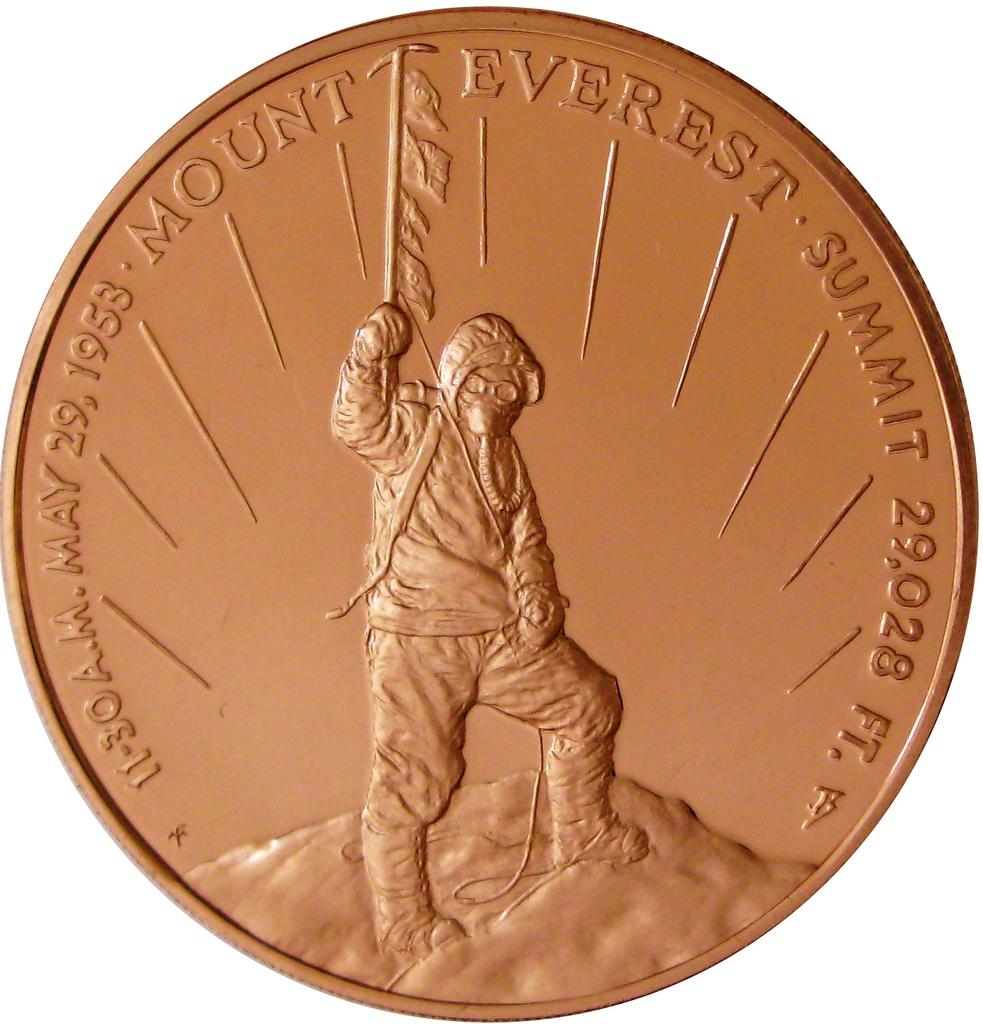Provide a one-sentence caption for the provided image. A bronze coin depicting the reaching of the summit of Everest in 1953. 